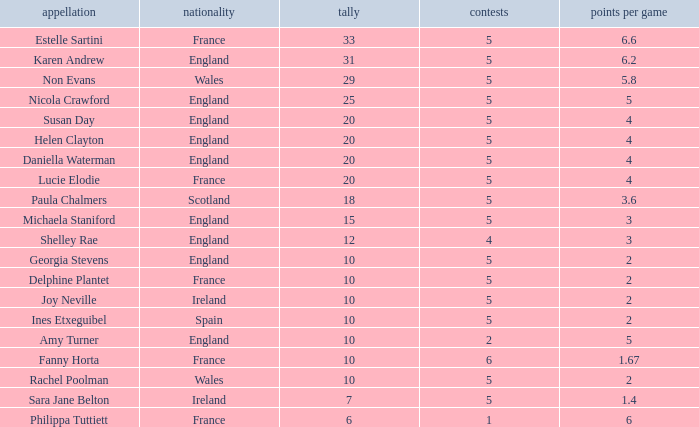Can you tell me the lowest Games that has the Pts/game larger than 1.4 and the Points of 20, and the Name of susan day? 5.0. 